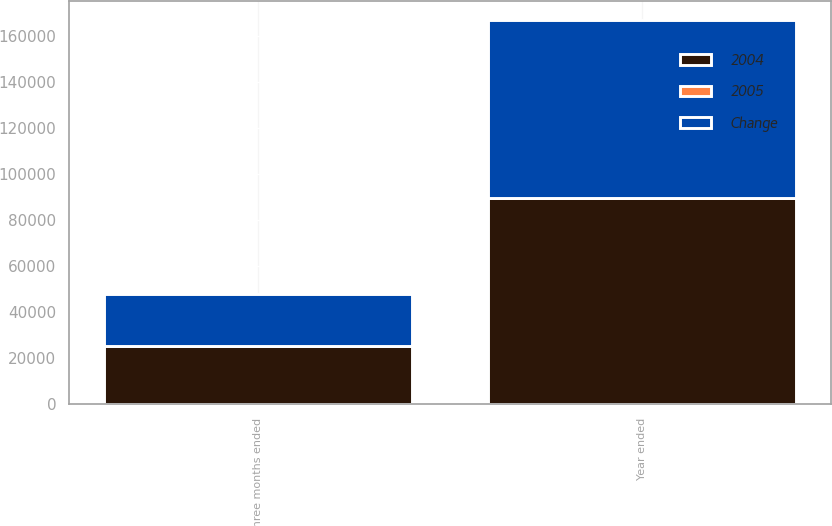<chart> <loc_0><loc_0><loc_500><loc_500><stacked_bar_chart><ecel><fcel>Three months ended<fcel>Year ended<nl><fcel>2004<fcel>25286<fcel>89707<nl><fcel>Change<fcel>22615<fcel>77062<nl><fcel>2005<fcel>11.8<fcel>16.4<nl></chart> 